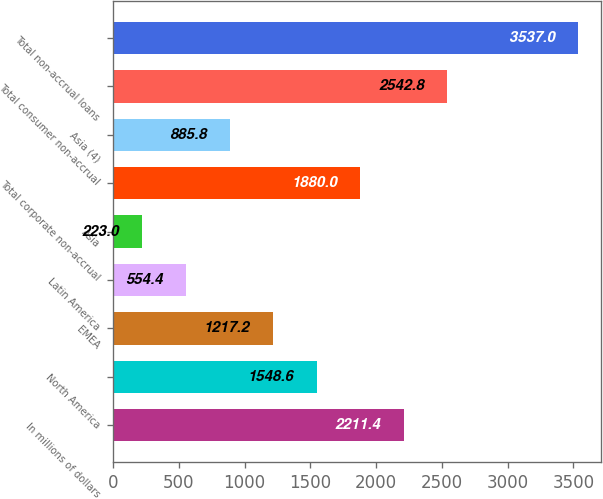Convert chart to OTSL. <chart><loc_0><loc_0><loc_500><loc_500><bar_chart><fcel>In millions of dollars<fcel>North America<fcel>EMEA<fcel>Latin America<fcel>Asia<fcel>Total corporate non-accrual<fcel>Asia (4)<fcel>Total consumer non-accrual<fcel>Total non-accrual loans<nl><fcel>2211.4<fcel>1548.6<fcel>1217.2<fcel>554.4<fcel>223<fcel>1880<fcel>885.8<fcel>2542.8<fcel>3537<nl></chart> 